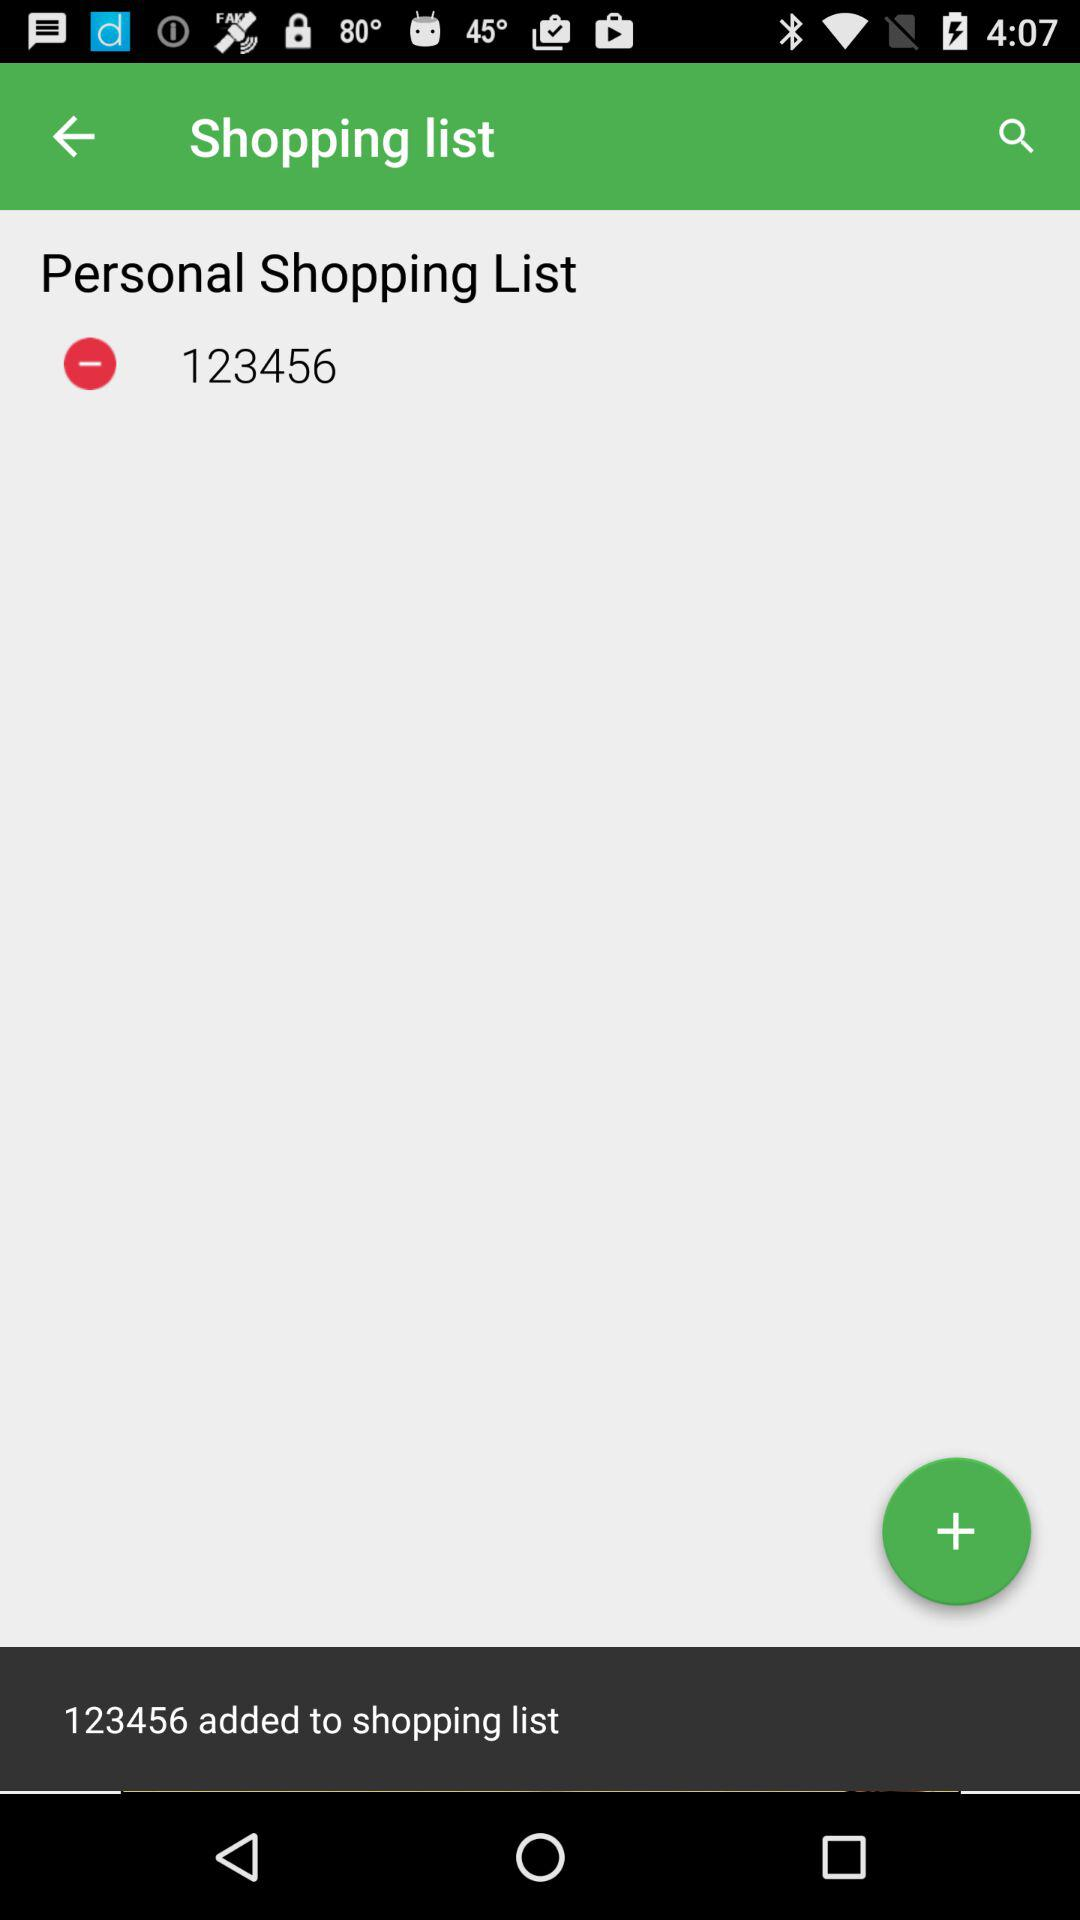Who is "Shopping list" powered by?
When the provided information is insufficient, respond with <no answer>. <no answer> 